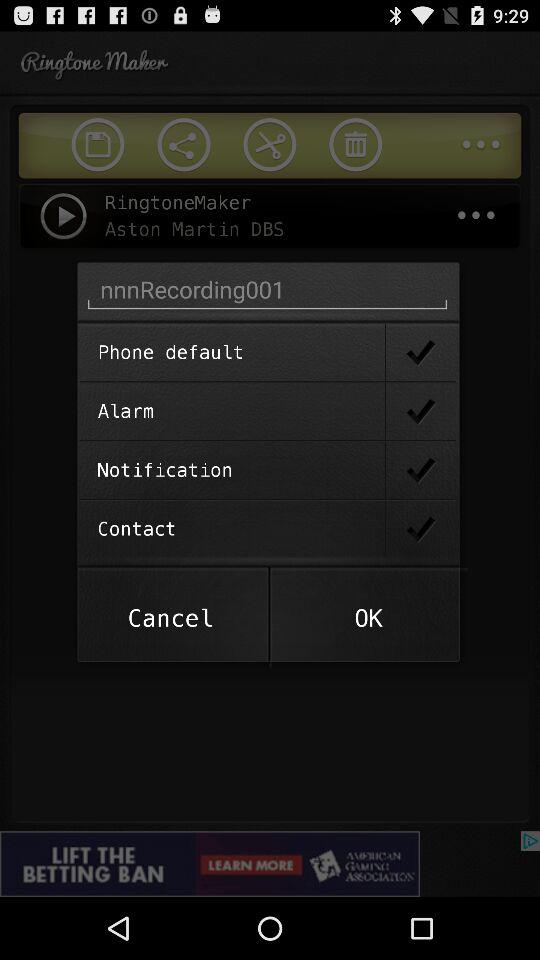What is the application name? The application name is "Ringtone Maker". 